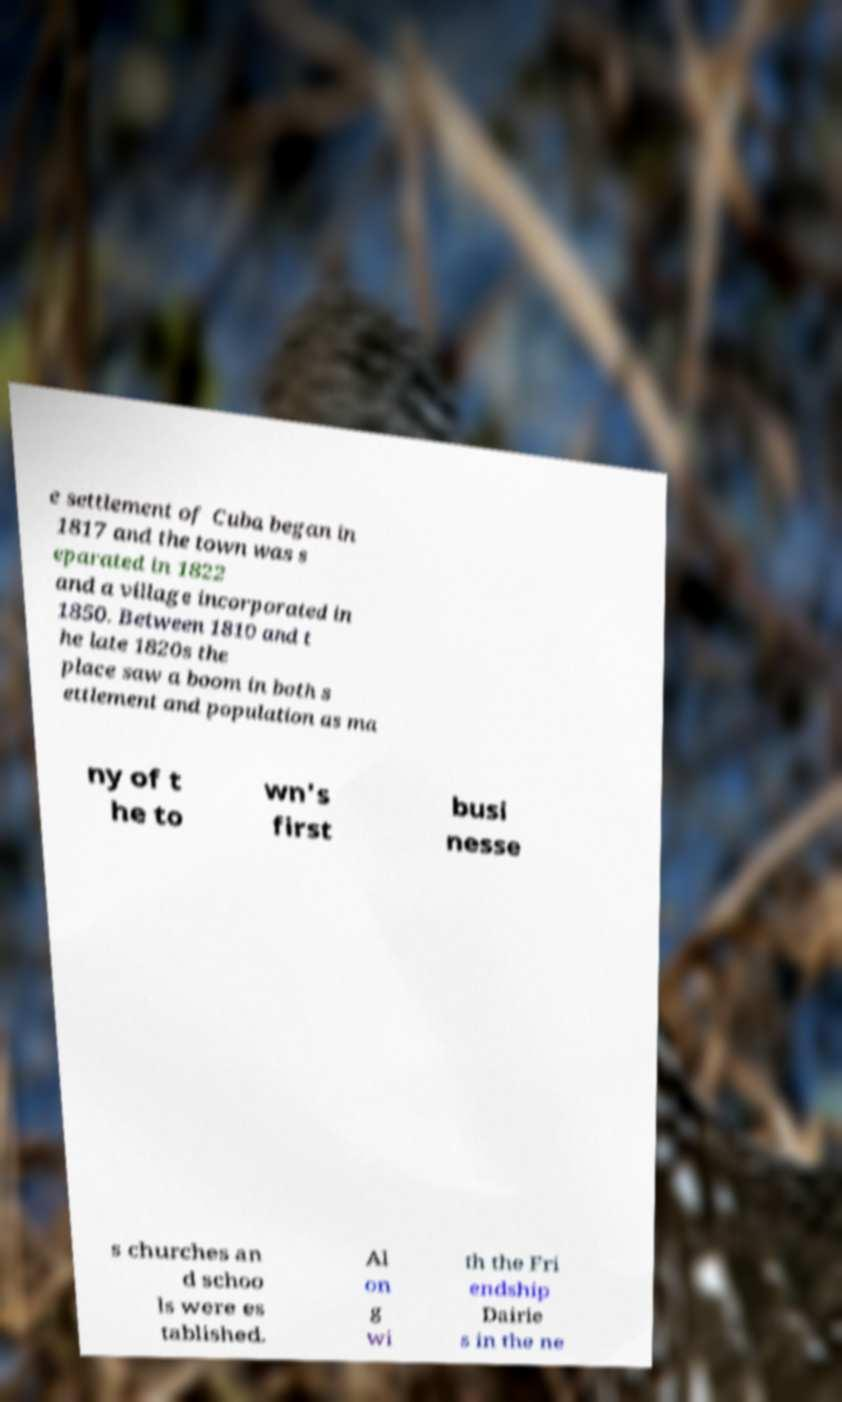What messages or text are displayed in this image? I need them in a readable, typed format. e settlement of Cuba began in 1817 and the town was s eparated in 1822 and a village incorporated in 1850. Between 1810 and t he late 1820s the place saw a boom in both s ettlement and population as ma ny of t he to wn's first busi nesse s churches an d schoo ls were es tablished. Al on g wi th the Fri endship Dairie s in the ne 